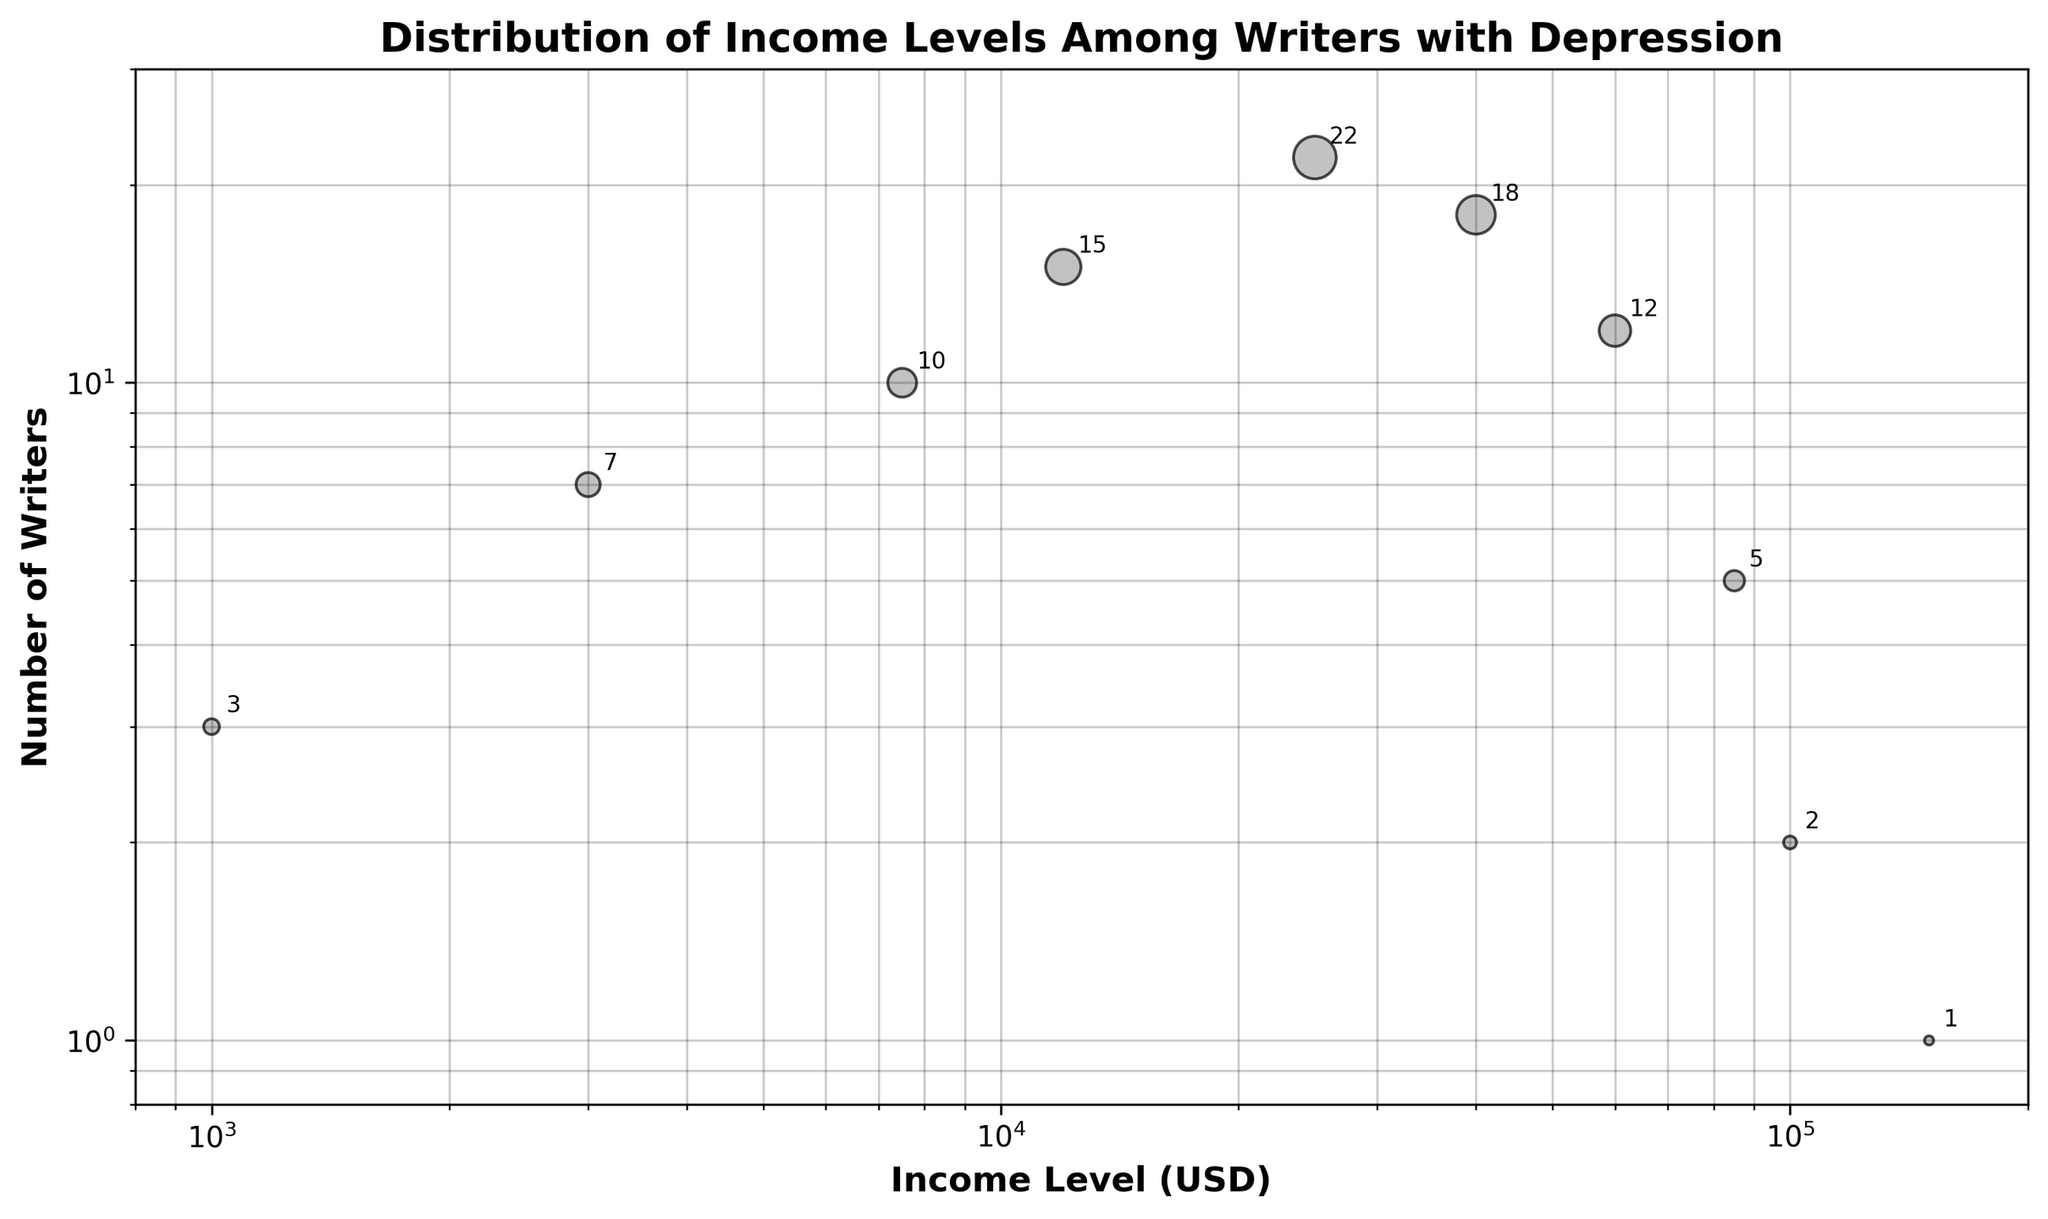What's the title of the figure? The title is located at the top center of the figure, usually in a bold font. It provides a summary of what the plot represents.
Answer: Distribution of Income Levels Among Writers with Depression How many different income levels are shown in the figure? Count the distinct data points on the x-axis (Income Level (USD)). Each point represents a different income level.
Answer: 10 Which income level has the highest number of writers? Look for the highest y-value (Number of Writers) and check the corresponding x-value (Income Level (USD)).
Answer: 25000 Compare the number of writers in the income levels 1000 USD and 100000 USD. Which one is greater? Identify the y-values for x = 1000 USD and x = 100000 USD, then compare both values. The y-value for 1000 USD is 3, and for 100000 USD is 2.
Answer: 1000 USD What is the average number of writers for income levels below 5000 USD? Identify the income levels below 5000 USD (1000, 3000), sum their y-values (3 + 7), and divide by the number of these income levels (2).
Answer: 5 Do any income levels have the same number of writers? Check the y-values to see if any of them are repeated. Here, no y-values are repeated exactly.
Answer: No What is the total number of writers shown in the figure? Sum all the y-values (3 + 7 + 10 + 15 + 22 + 18 + 12 + 5 + 2 + 1).
Answer: 95 Which income range (interval) has the largest spread in the number of writers? Compare the number of writers across different income ranges by identifying the largest difference in y-values within any income interval (eg. 3 to 22 between 1000 and 25000 USD). The interval between 1000 USD and 25000 USD spans from 3 to 22 writers.
Answer: 1000 USD-25000 USD What's the income level and number of writers at the second-highest income level? Reviewing the x-values, the second-highest income level is 100000 USD, and checking its corresponding y-value gives the number of writers.
Answer: 100000 USD, 2 